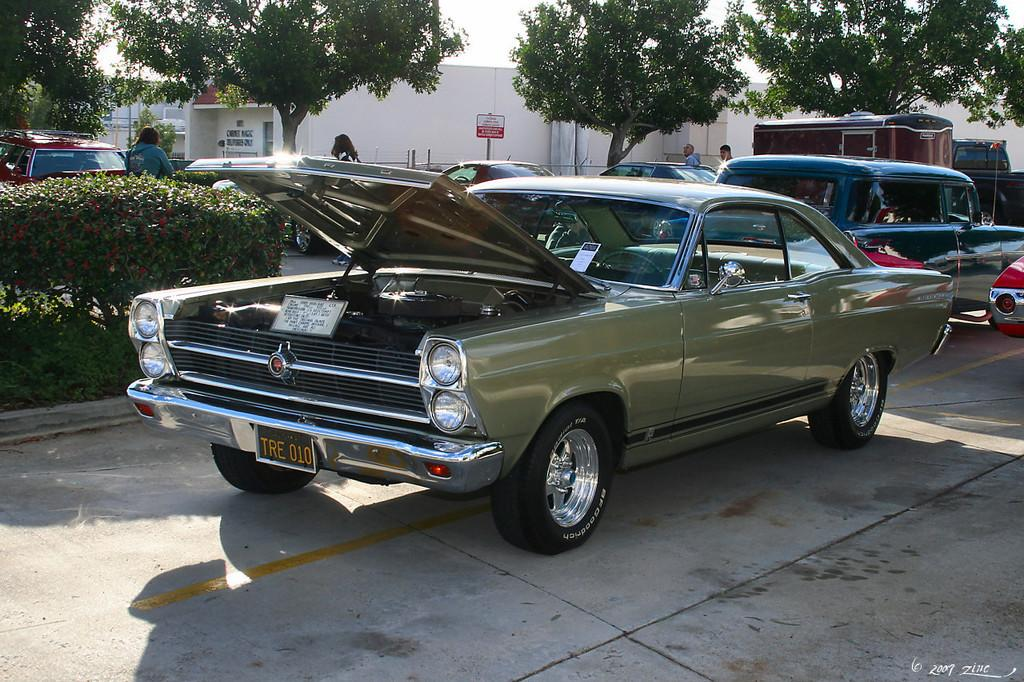What is the main subject of the image? The main subject of the image is cars on a road. Are there any people visible in the image? Yes, there are people standing near the cars in the background. What can be seen in the background of the image? There are trees and buildings in the background of the image. What type of fish can be seen swimming in the image? There are no fish present in the image; it features cars on a road with people and background elements. 